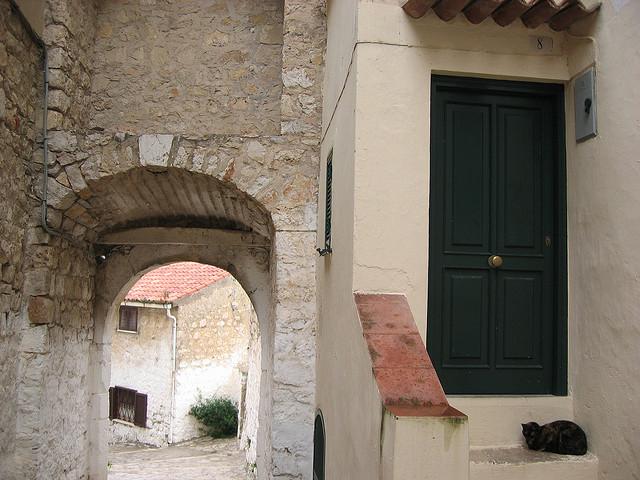What are the walls made of?
Keep it brief. Stone. What type of animal is in the southeast corner of the picture?
Give a very brief answer. Cat. What direction is the door facing?
Answer briefly. Out. 